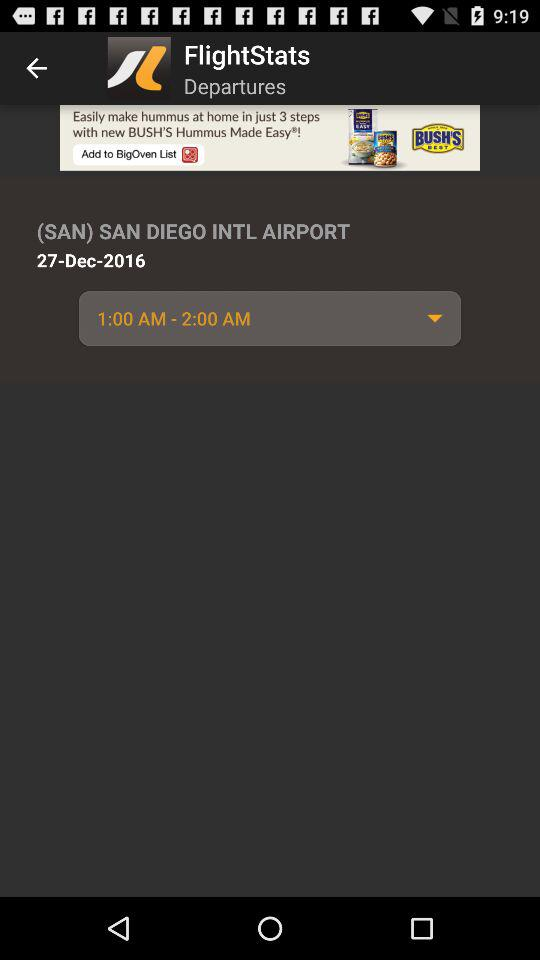What is the location? The location is (SAN) San Diego International Airport. 